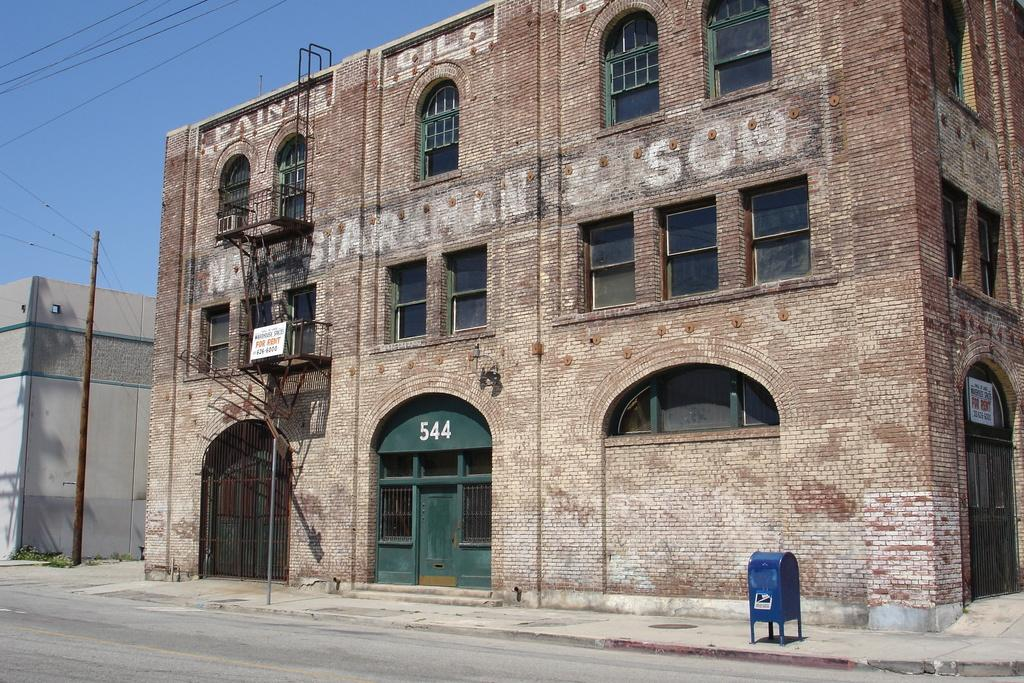What is the main subject of the image? The image depicts a road. What structures can be seen alongside the road? There are buildings visible in the image. What architectural features areal features can be observed on the buildings? Windows and doors are visible in the image. What additional objects are present in the image? Boards and poles are present in the image. What can be seen in the background of the image? The sky is visible in the background of the image. How many feet are visible on the shelf in the image? There is no shelf present in the image, and therefore no feet can be observed. 